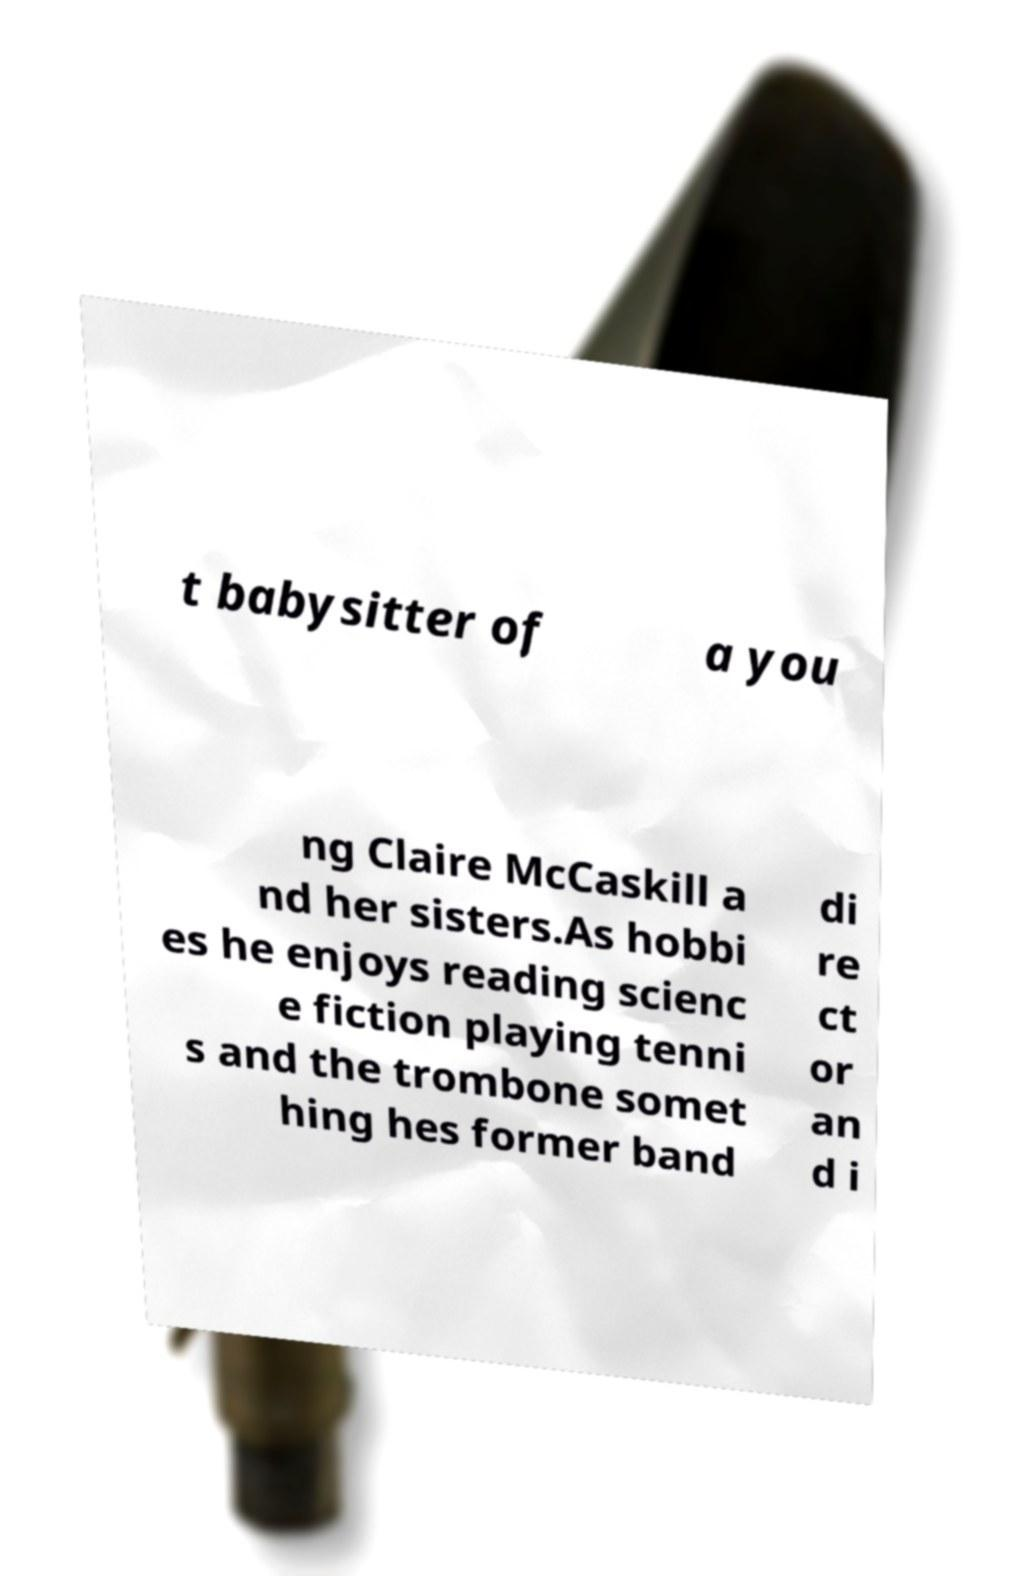There's text embedded in this image that I need extracted. Can you transcribe it verbatim? t babysitter of a you ng Claire McCaskill a nd her sisters.As hobbi es he enjoys reading scienc e fiction playing tenni s and the trombone somet hing hes former band di re ct or an d i 